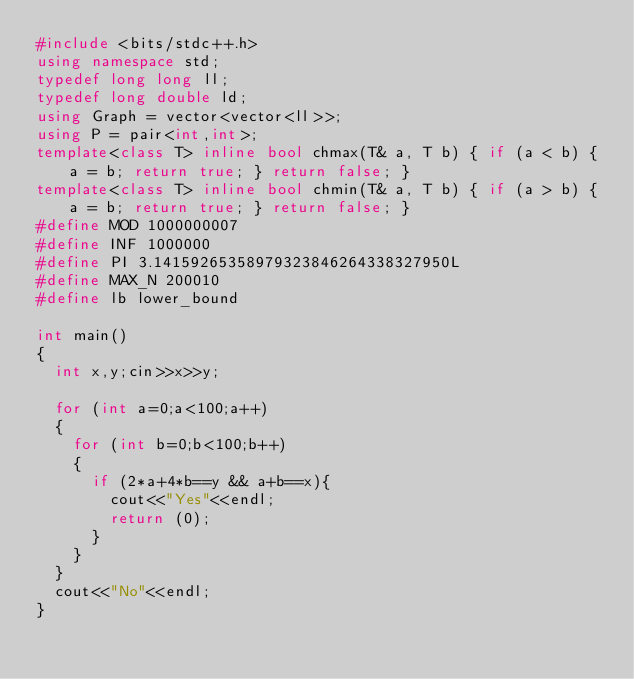Convert code to text. <code><loc_0><loc_0><loc_500><loc_500><_C++_>#include <bits/stdc++.h>
using namespace std;
typedef long long ll;
typedef long double ld;
using Graph = vector<vector<ll>>;
using P = pair<int,int>;
template<class T> inline bool chmax(T& a, T b) { if (a < b) { a = b; return true; } return false; }
template<class T> inline bool chmin(T& a, T b) { if (a > b) { a = b; return true; } return false; }
#define MOD 1000000007
#define INF 1000000
#define PI 3.14159265358979323846264338327950L
#define MAX_N 200010
#define lb lower_bound 

int main()
{
  int x,y;cin>>x>>y;
  
  for (int a=0;a<100;a++)
  {
    for (int b=0;b<100;b++)
    {
      if (2*a+4*b==y && a+b==x){
        cout<<"Yes"<<endl;
        return (0);
      }
    }
  }
  cout<<"No"<<endl;
}</code> 